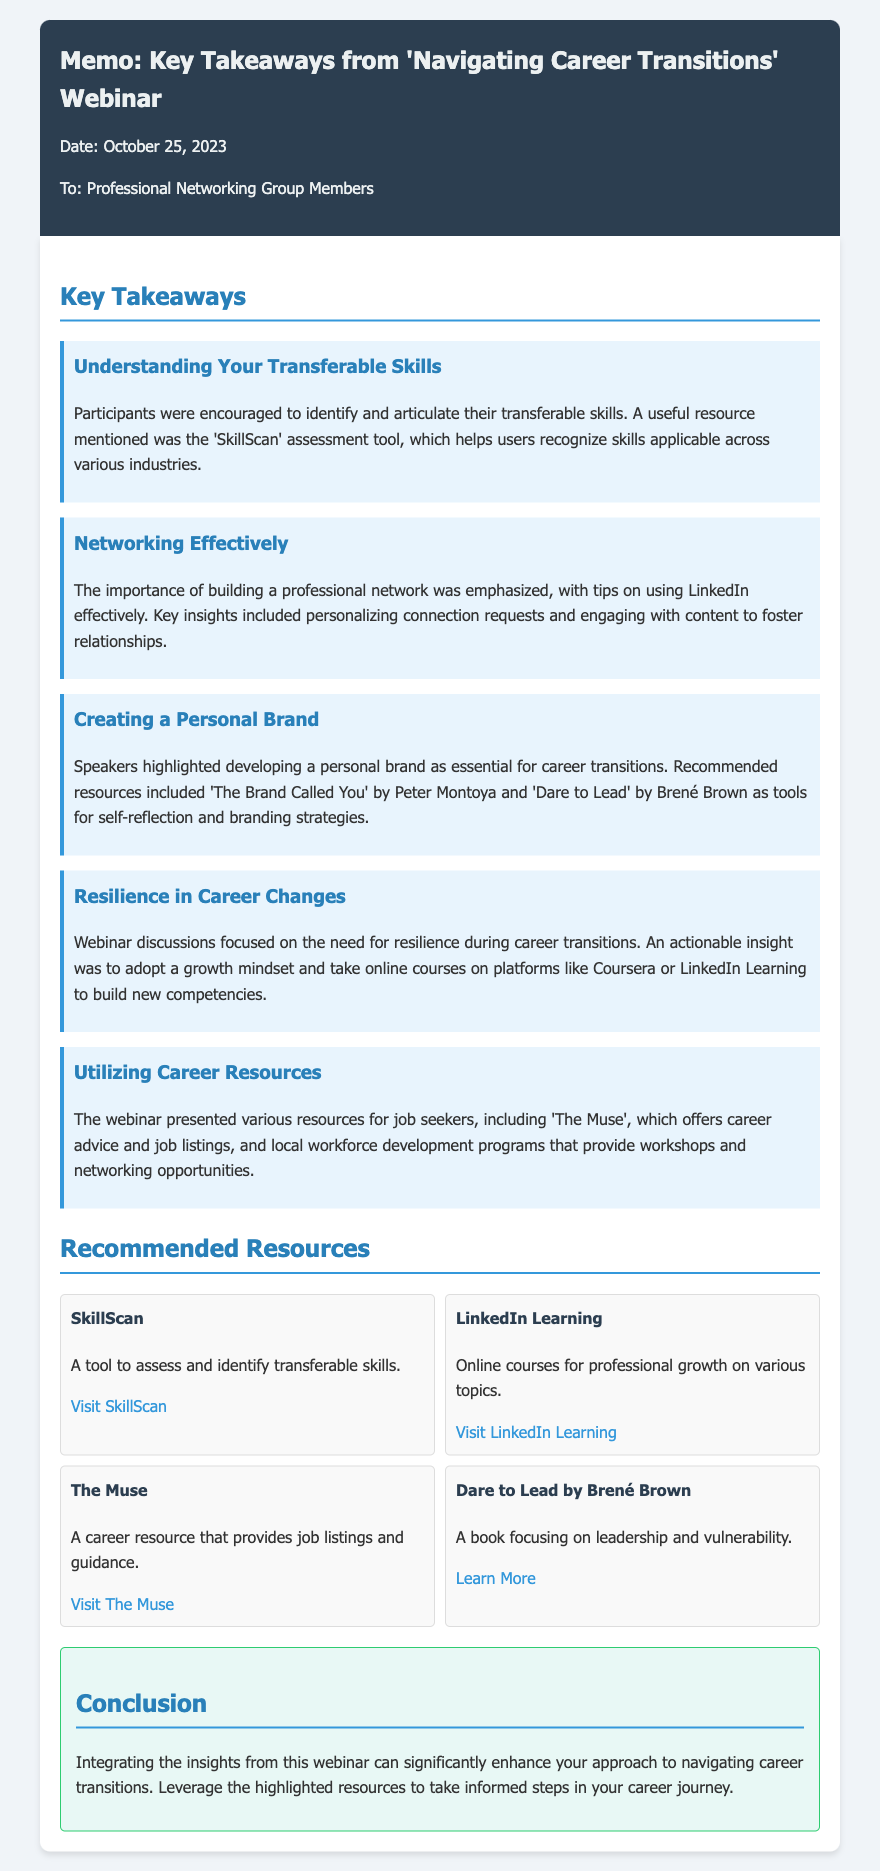What is the date of the webinar? The date of the webinar is mentioned in the memo header as October 25, 2023.
Answer: October 25, 2023 Who is the target audience of the memo? The memo indicates that it is addressed to members of the Professional Networking Group.
Answer: Professional Networking Group Members What is the first key takeaway discussed in the webinar? The first key takeaway focuses on identifying and articulating transferable skills.
Answer: Understanding Your Transferable Skills Which tool is recommended for assessing transferable skills? The memo specifically mentions the 'SkillScan' assessment tool for this purpose.
Answer: SkillScan What book is suggested for developing a personal brand? The title of the recommended book for personal branding is 'The Brand Called You' by Peter Montoya.
Answer: The Brand Called You How many resources are recommended in the document? The document features a list of four key resources.
Answer: Four What is an actionable insight regarding resilience during career transitions? The memo highlights the importance of adopting a growth mindset as an actionable insight.
Answer: Adopt a growth mindset What is the concluding message of the memo? The conclusion emphasizes leveraging the insights from the webinar for career transitions.
Answer: Leverage the highlighted resources 